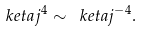<formula> <loc_0><loc_0><loc_500><loc_500>\ k e t a { j ^ { 4 } } \sim \ k e t a { j ^ { - 4 } } .</formula> 